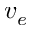<formula> <loc_0><loc_0><loc_500><loc_500>v _ { e }</formula> 